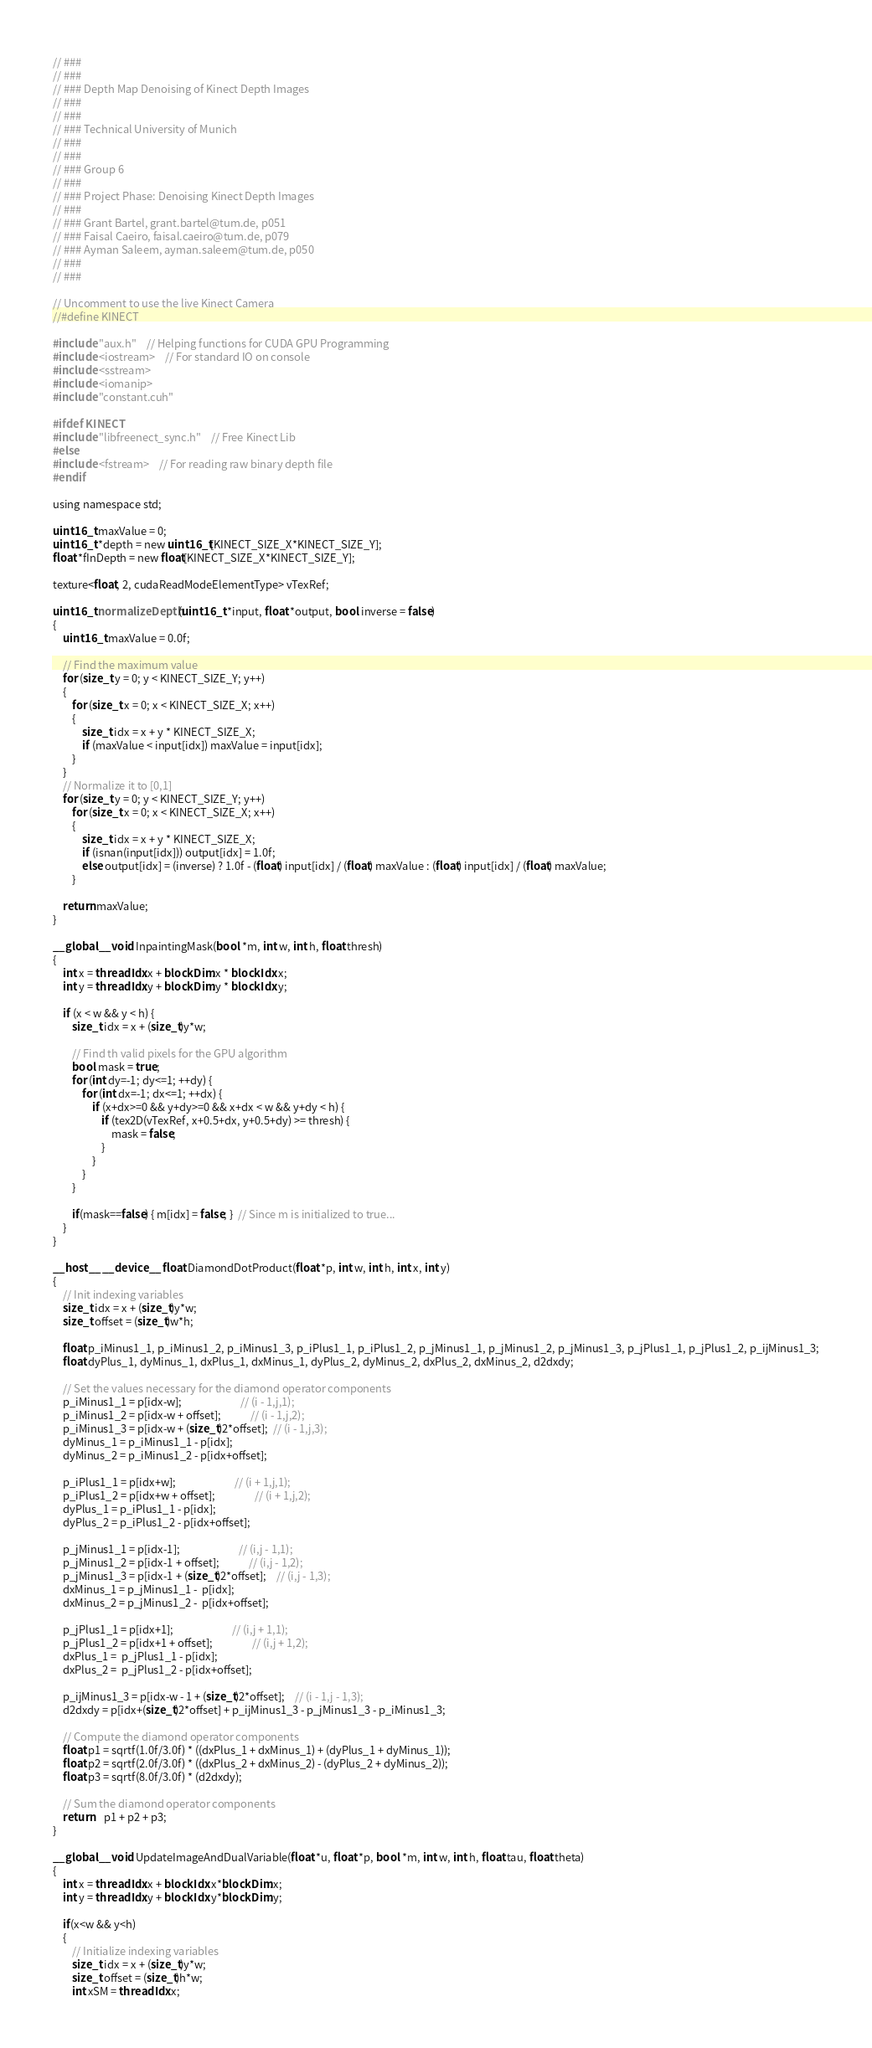<code> <loc_0><loc_0><loc_500><loc_500><_Cuda_>// ###
// ###
// ### Depth Map Denoising of Kinect Depth Images
// ### 
// ###
// ### Technical University of Munich
// ###
// ### 
// ### Group 6
// ### 
// ### Project Phase: Denoising Kinect Depth Images
// ###
// ### Grant Bartel, grant.bartel@tum.de, p051
// ### Faisal Caeiro, faisal.caeiro@tum.de, p079
// ### Ayman Saleem, ayman.saleem@tum.de, p050
// ###
// ###

// Uncomment to use the live Kinect Camera
//#define KINECT

#include "aux.h"	// Helping functions for CUDA GPU Programming
#include <iostream>	// For standard IO on console
#include <sstream>
#include <iomanip>
#include "constant.cuh"

#ifdef KINECT
#include "libfreenect_sync.h"	// Free Kinect Lib
#else
#include <fstream>	// For reading raw binary depth file
#endif

using namespace std;

uint16_t maxValue = 0;
uint16_t *depth = new uint16_t[KINECT_SIZE_X*KINECT_SIZE_Y];
float *fInDepth = new float[KINECT_SIZE_X*KINECT_SIZE_Y];

texture<float, 2, cudaReadModeElementType> vTexRef;

uint16_t normalizeDepth(uint16_t *input, float *output, bool inverse = false)
{
	uint16_t maxValue = 0.0f;

	// Find the maximum value
	for (size_t y = 0; y < KINECT_SIZE_Y; y++)
	{
		for (size_t x = 0; x < KINECT_SIZE_X; x++)
		{
			size_t idx = x + y * KINECT_SIZE_X;
			if (maxValue < input[idx]) maxValue = input[idx];
		}
	}
	// Normalize it to [0,1]
	for (size_t y = 0; y < KINECT_SIZE_Y; y++)
		for (size_t x = 0; x < KINECT_SIZE_X; x++)
		{
			size_t idx = x + y * KINECT_SIZE_X;
			if (isnan(input[idx])) output[idx] = 1.0f;
			else output[idx] = (inverse) ? 1.0f - (float) input[idx] / (float) maxValue : (float) input[idx] / (float) maxValue;
		}

    return maxValue;
}

__global__ void InpaintingMask(bool *m, int w, int h, float thresh)
{
	int x = threadIdx.x + blockDim.x * blockIdx.x;
	int y = threadIdx.y + blockDim.y * blockIdx.y;

	if (x < w && y < h) { 
		size_t idx = x + (size_t)y*w;
		
        // Find th valid pixels for the GPU algorithm
	    bool mask = true;
	    for (int dy=-1; dy<=1; ++dy) {
		    for (int dx=-1; dx<=1; ++dx) {
			    if (x+dx>=0 && y+dy>=0 && x+dx < w && y+dy < h) {
				    if (tex2D(vTexRef, x+0.5+dx, y+0.5+dy) >= thresh) {
					    mask = false;
				    }
			    }
		    }
	    }
	    
        if(mask==false) { m[idx] = false; }  // Since m is initialized to true...
	}
}

__host__ __device__ float DiamondDotProduct(float *p, int w, int h, int x, int y)
{
    // Init indexing variables
    size_t idx = x + (size_t)y*w;
    size_t offset = (size_t)w*h;
    
    float p_iMinus1_1, p_iMinus1_2, p_iMinus1_3, p_iPlus1_1, p_iPlus1_2, p_jMinus1_1, p_jMinus1_2, p_jMinus1_3, p_jPlus1_1, p_jPlus1_2, p_ijMinus1_3;
    float dyPlus_1, dyMinus_1, dxPlus_1, dxMinus_1, dyPlus_2, dyMinus_2, dxPlus_2, dxMinus_2, d2dxdy;

    // Set the values necessary for the diamond operator components
    p_iMinus1_1 = p[idx-w];	                    // (i - 1,j,1);   
    p_iMinus1_2 = p[idx-w + offset];            // (i - 1,j,2);
    p_iMinus1_3 = p[idx-w + (size_t)2*offset];  // (i - 1,j,3);   
    dyMinus_1 = p_iMinus1_1 - p[idx];       
    dyMinus_2 = p_iMinus1_2 - p[idx+offset];

    p_iPlus1_1 = p[idx+w];	                    // (i + 1,j,1);    
    p_iPlus1_2 = p[idx+w + offset];	            // (i + 1,j,2); 
    dyPlus_1 = p_iPlus1_1 - p[idx];
    dyPlus_2 = p_iPlus1_2 - p[idx+offset];

    p_jMinus1_1 = p[idx-1];	                    // (i,j - 1,1);   
    p_jMinus1_2 = p[idx-1 + offset];	        // (i,j - 1,2); 
    p_jMinus1_3 = p[idx-1 + (size_t)2*offset];	// (i,j - 1,3); 
    dxMinus_1 = p_jMinus1_1 -  p[idx];
    dxMinus_2 = p_jMinus1_2 -  p[idx+offset];

    p_jPlus1_1 = p[idx+1];	                    // (i,j + 1,1);    
    p_jPlus1_2 = p[idx+1 + offset];	            // (i,j + 1,2);
    dxPlus_1 =  p_jPlus1_1 - p[idx];
    dxPlus_2 =  p_jPlus1_2 - p[idx+offset];

    p_ijMinus1_3 = p[idx-w - 1 + (size_t)2*offset];	// (i - 1,j - 1,3);
    d2dxdy = p[idx+(size_t)2*offset] + p_ijMinus1_3 - p_jMinus1_3 - p_iMinus1_3;

    // Compute the diamond operator components
    float p1 = sqrtf(1.0f/3.0f) * ((dxPlus_1 + dxMinus_1) + (dyPlus_1 + dyMinus_1));
    float p2 = sqrtf(2.0f/3.0f) * ((dxPlus_2 + dxMinus_2) - (dyPlus_2 + dyMinus_2));
    float p3 = sqrtf(8.0f/3.0f) * (d2dxdy);

    // Sum the diamond operator components
    return	p1 + p2 + p3;
}

__global__ void UpdateImageAndDualVariable(float *u, float *p, bool *m, int w, int h, float tau, float theta)
{
    int x = threadIdx.x + blockIdx.x*blockDim.x;
    int y = threadIdx.y + blockIdx.y*blockDim.y;

    if(x<w && y<h)
    {
        // Initialize indexing variables
        size_t idx = x + (size_t)y*w;
        size_t offset = (size_t)h*w;
        int xSM = threadIdx.x;</code> 